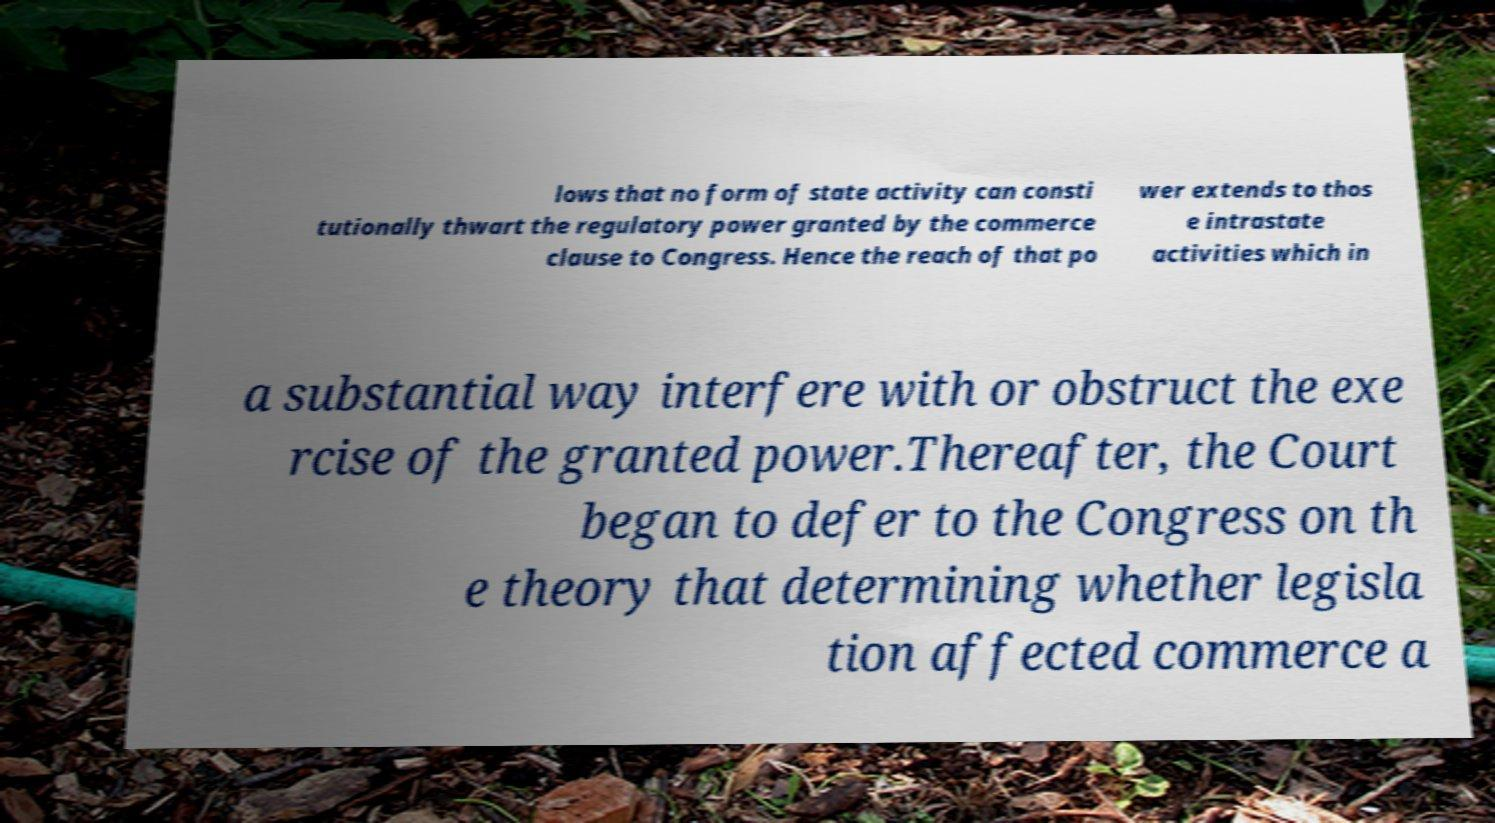Please identify and transcribe the text found in this image. lows that no form of state activity can consti tutionally thwart the regulatory power granted by the commerce clause to Congress. Hence the reach of that po wer extends to thos e intrastate activities which in a substantial way interfere with or obstruct the exe rcise of the granted power.Thereafter, the Court began to defer to the Congress on th e theory that determining whether legisla tion affected commerce a 